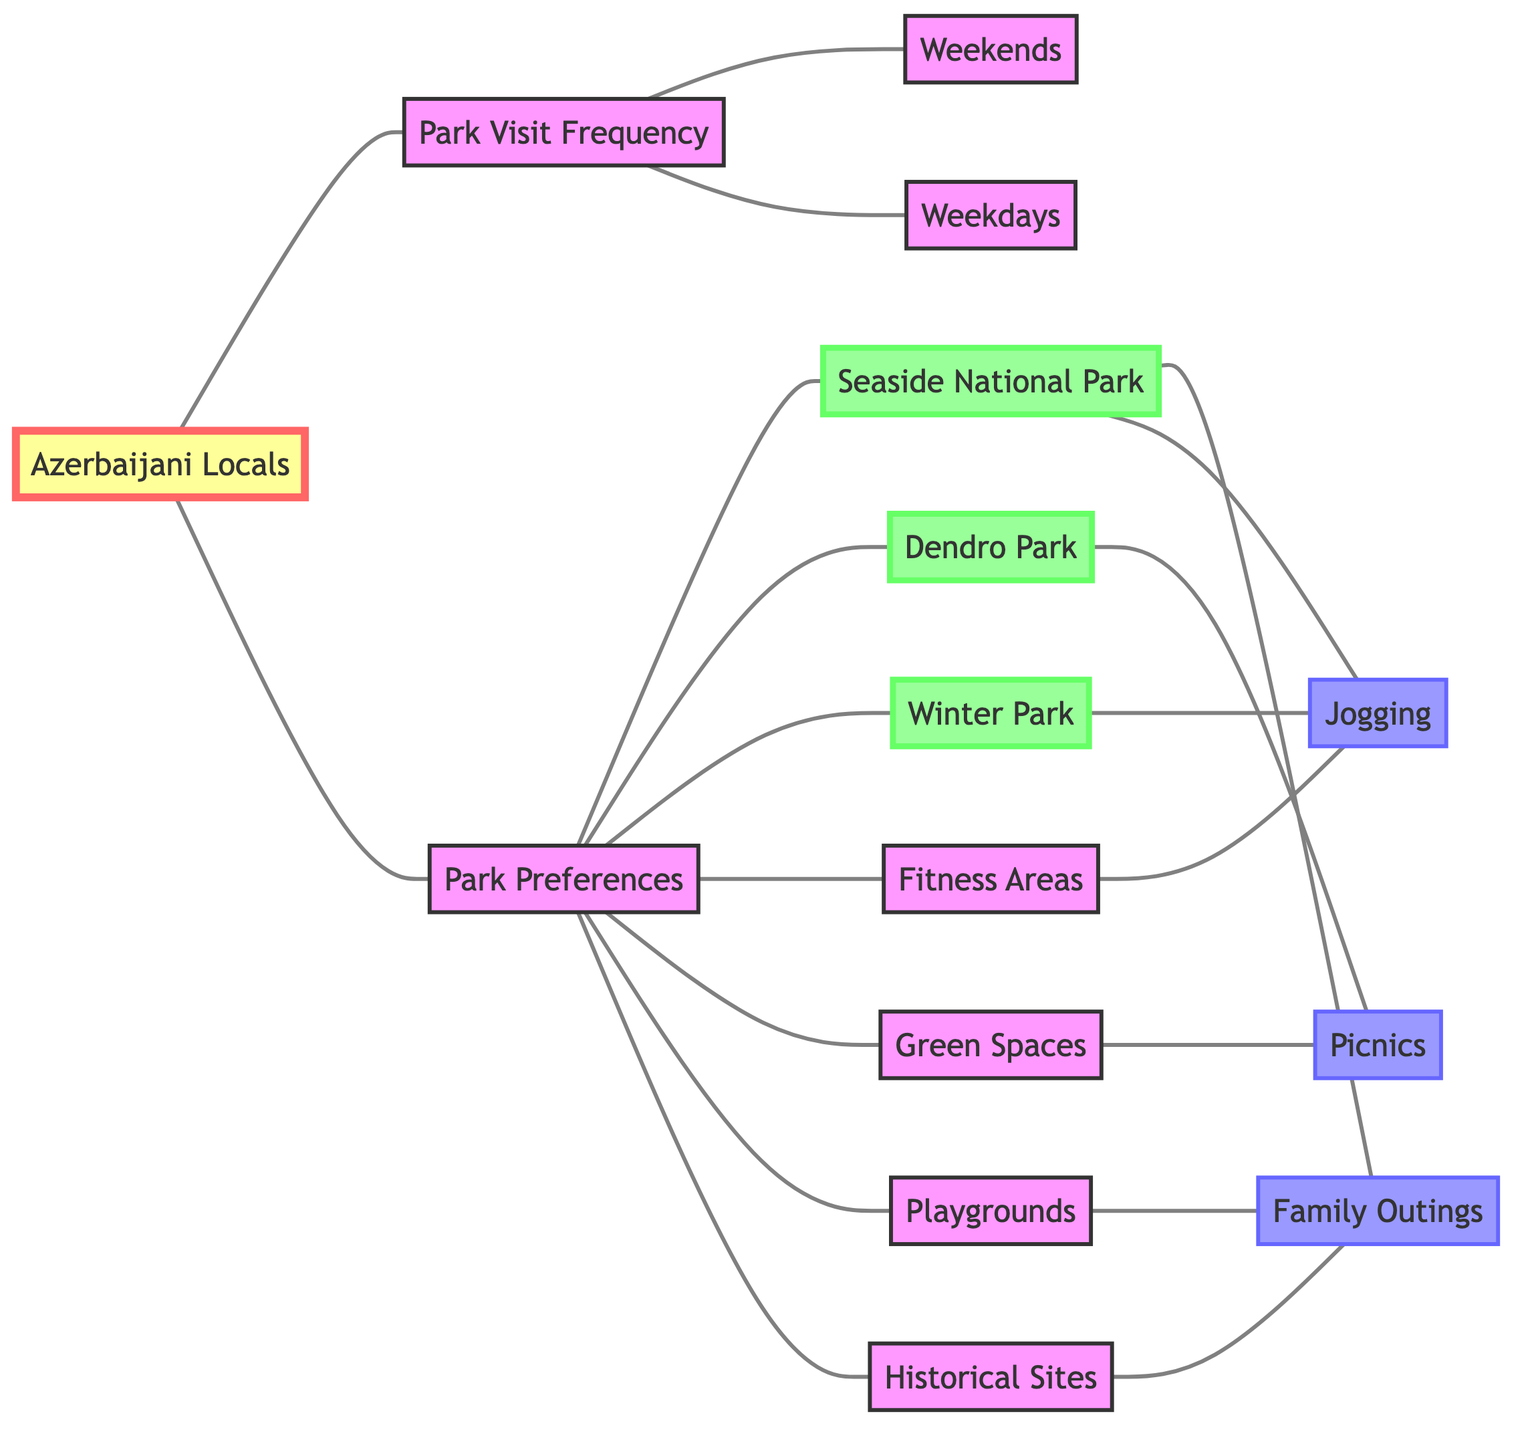What is the connection between Azerbaijani Locals and Park Visit Frequency? The Azerbaijani Locals node is directly connected to the Park Visit Frequency node, indicating that these locals have a relationship with how often they visit parks.
Answer: Park Visit Frequency How many parks are listed in the diagram? The diagram shows three parks: Seaside National Park, Dendro Park, and Winter Park, as indicated by the connections from the Park Preferences node.
Answer: 3 What activity is associated with the Seaside National Park? The diagram links the Seaside National Park to two activities: Family Outings and Jogging, meaning both activities are preferences for visitors of this park.
Answer: Family Outings, Jogging Which day is more likely for Azerbaijani locals to visit parks? The Park Visit Frequency node connects to both Weekends and Weekdays, but typically, weekends are more popular for leisure activities, suggesting locals might prefer weekends for park visits.
Answer: Weekends Which park is linked to picnics? The diagram indicates that Dendro Park has a direct connection to the activity of Picnics, showing a clear association.
Answer: Dendro Park How many activities are directly connected to Park Preferences? The Park Preferences node connects to six different activities: Family Outings, Jogging, Picnics, along with Fitness Areas, Green Spaces, and Playgrounds, making a total of six activities.
Answer: 6 Which type of space is preferred for recreational activities in the parks? The diagram shows that Fitness Areas and Green Spaces are linked to activities like Jogging and Picnics, indicating a preference for these types of spaces for recreation.
Answer: Fitness Areas, Green Spaces Is there a direct relationship between Family Outings and Historical Sites? Yes, the diagram directly links Historical Sites with Family Outings, indicating that both nodes are associated with the same preference for Azerbaijani locals when visiting parks.
Answer: Yes Which park has a jogging activity associated with it? The Winter Park has a direct connection to the Jogging activity, indicating this park supports jogging as one of its recreational options.
Answer: Winter Park 